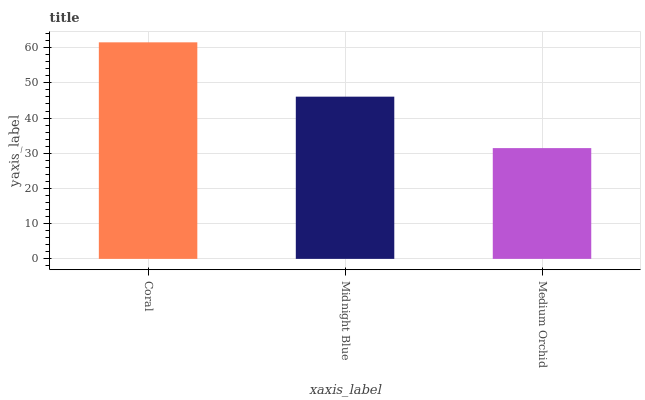Is Medium Orchid the minimum?
Answer yes or no. Yes. Is Coral the maximum?
Answer yes or no. Yes. Is Midnight Blue the minimum?
Answer yes or no. No. Is Midnight Blue the maximum?
Answer yes or no. No. Is Coral greater than Midnight Blue?
Answer yes or no. Yes. Is Midnight Blue less than Coral?
Answer yes or no. Yes. Is Midnight Blue greater than Coral?
Answer yes or no. No. Is Coral less than Midnight Blue?
Answer yes or no. No. Is Midnight Blue the high median?
Answer yes or no. Yes. Is Midnight Blue the low median?
Answer yes or no. Yes. Is Medium Orchid the high median?
Answer yes or no. No. Is Coral the low median?
Answer yes or no. No. 